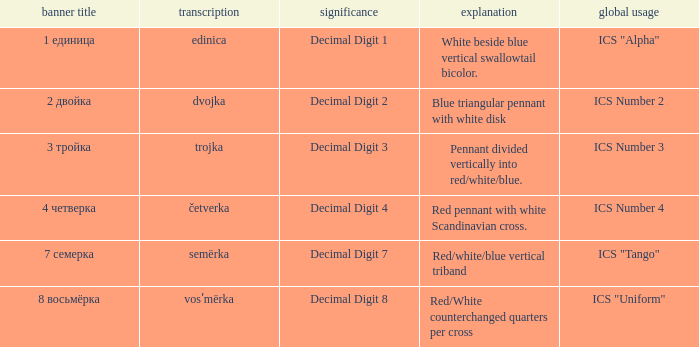What are the meanings of the flag whose name transliterates to dvojka? Decimal Digit 2. 